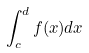<formula> <loc_0><loc_0><loc_500><loc_500>\int _ { c } ^ { d } f ( x ) d x</formula> 